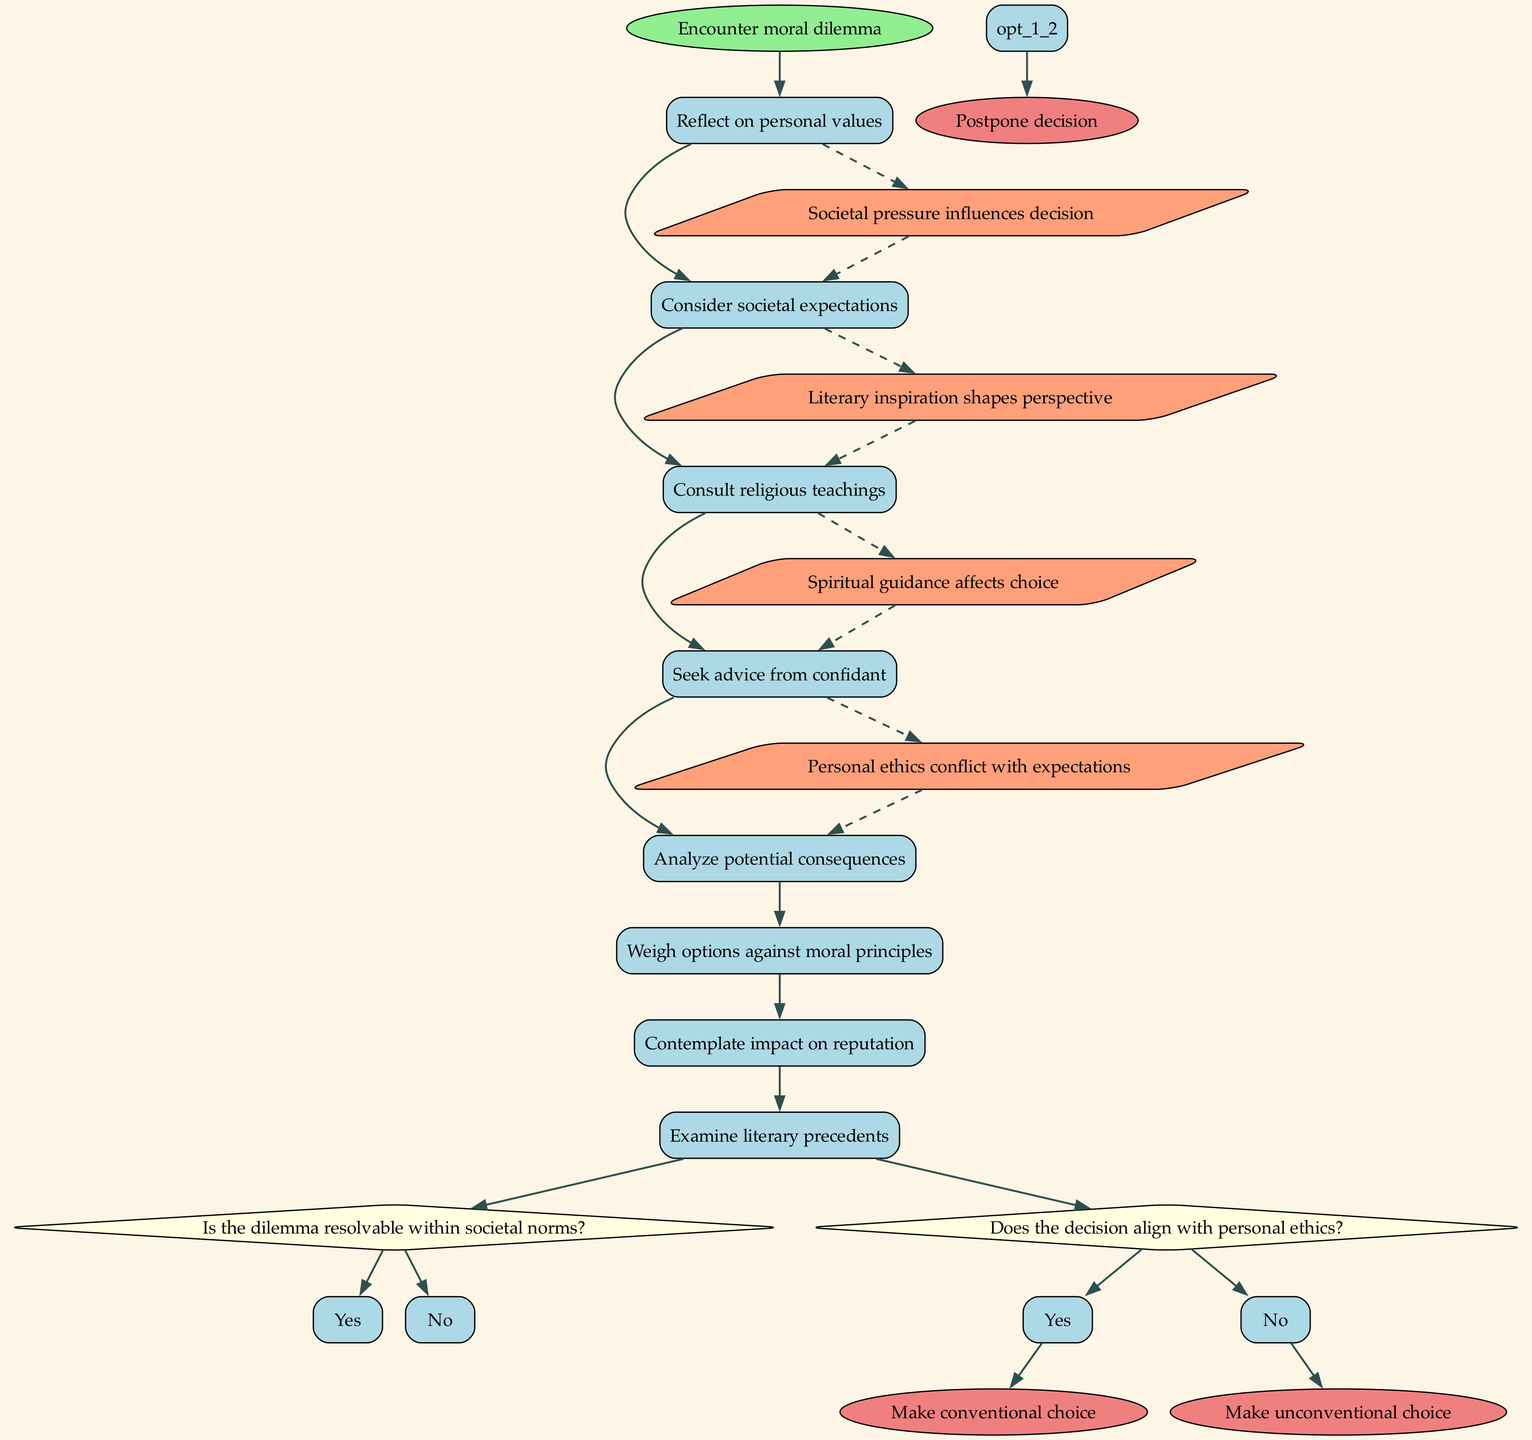What is the initial node in the diagram? The initial node, which represents the starting point of the decision-making process, is labeled as "Encounter moral dilemma."
Answer: Encounter moral dilemma How many activities are listed in the diagram? There are a total of 8 activities shown in the diagram connecting to the initial node.
Answer: 8 What question is posed as the first decision point? The first decision point in the diagram asks, "Is the dilemma resolvable within societal norms?"
Answer: Is the dilemma resolvable within societal norms? What are the two options available at the first decision point? The first decision point offers two options which are "Yes" and "No" as potential responses.
Answer: Yes, No Which final node corresponds to making a choice influenced by societal norms? The final node that corresponds to making a choice based on societal norms is "Make conventional choice."
Answer: Make conventional choice What type of influence is indicated by the dashed connections in the diagram? The dashed connections in the diagram indicate external influences impacting the decision-making process, such as societal pressure and literary inspiration.
Answer: External influences Which activity precedes contemplating the impact on reputation? Before contemplating the impact on reputation, the character must "Weigh options against moral principles." This activity flows sequentially before it.
Answer: Weigh options against moral principles How many final nodes are displayed in the diagram? There are a total of 3 final nodes presented at the conclusion of the decision-making process.
Answer: 3 What connection is made between examining literary precedents and making unconventional choices? The connection made is that "Literary inspiration shapes perspective," implying that examining literary precedents can influence the decision towards making unconventional choices.
Answer: Literary inspiration shapes perspective 